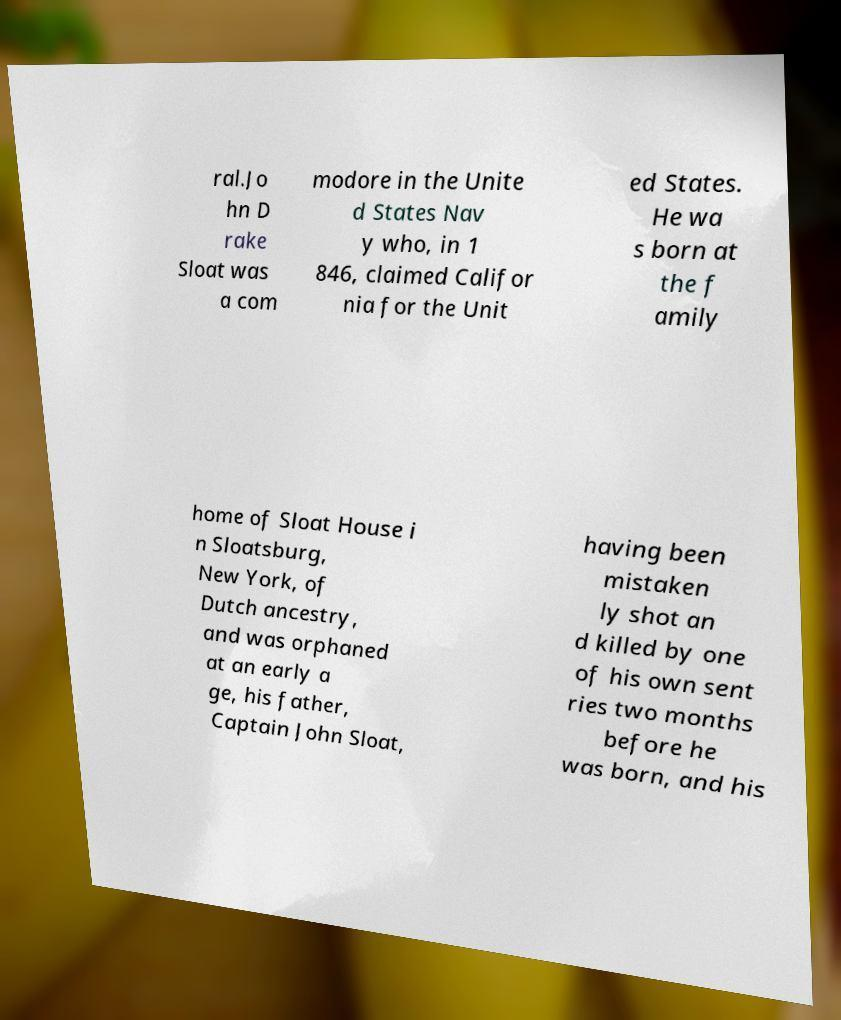Can you read and provide the text displayed in the image?This photo seems to have some interesting text. Can you extract and type it out for me? ral.Jo hn D rake Sloat was a com modore in the Unite d States Nav y who, in 1 846, claimed Califor nia for the Unit ed States. He wa s born at the f amily home of Sloat House i n Sloatsburg, New York, of Dutch ancestry, and was orphaned at an early a ge, his father, Captain John Sloat, having been mistaken ly shot an d killed by one of his own sent ries two months before he was born, and his 